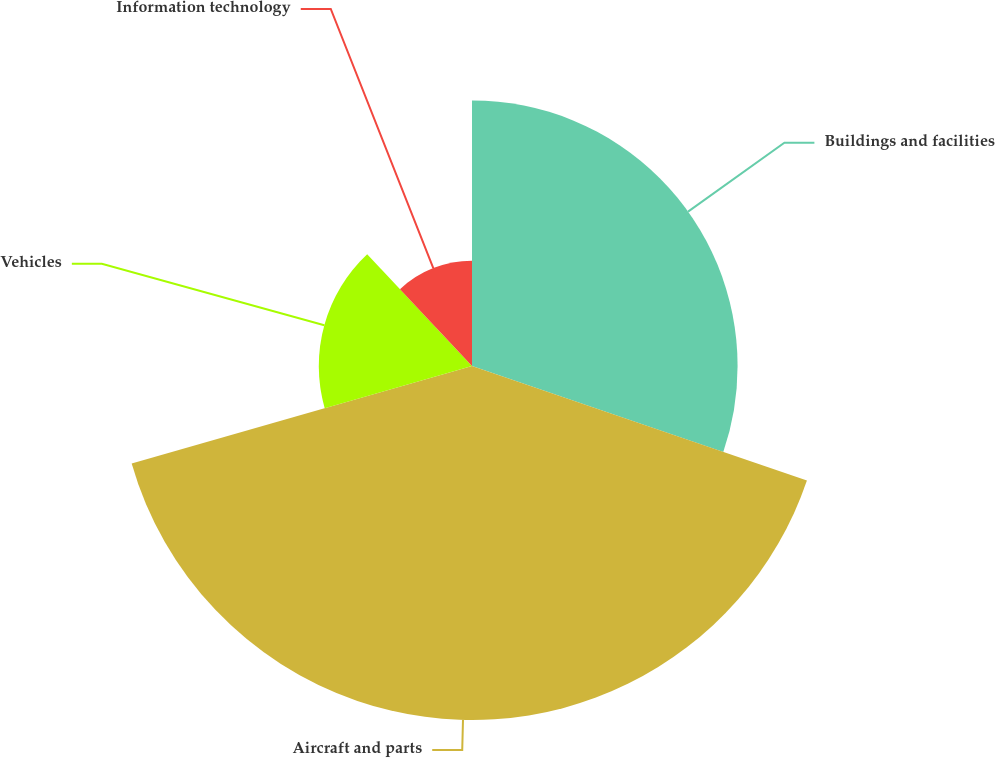Convert chart. <chart><loc_0><loc_0><loc_500><loc_500><pie_chart><fcel>Buildings and facilities<fcel>Aircraft and parts<fcel>Vehicles<fcel>Information technology<nl><fcel>30.25%<fcel>40.32%<fcel>17.45%<fcel>11.99%<nl></chart> 